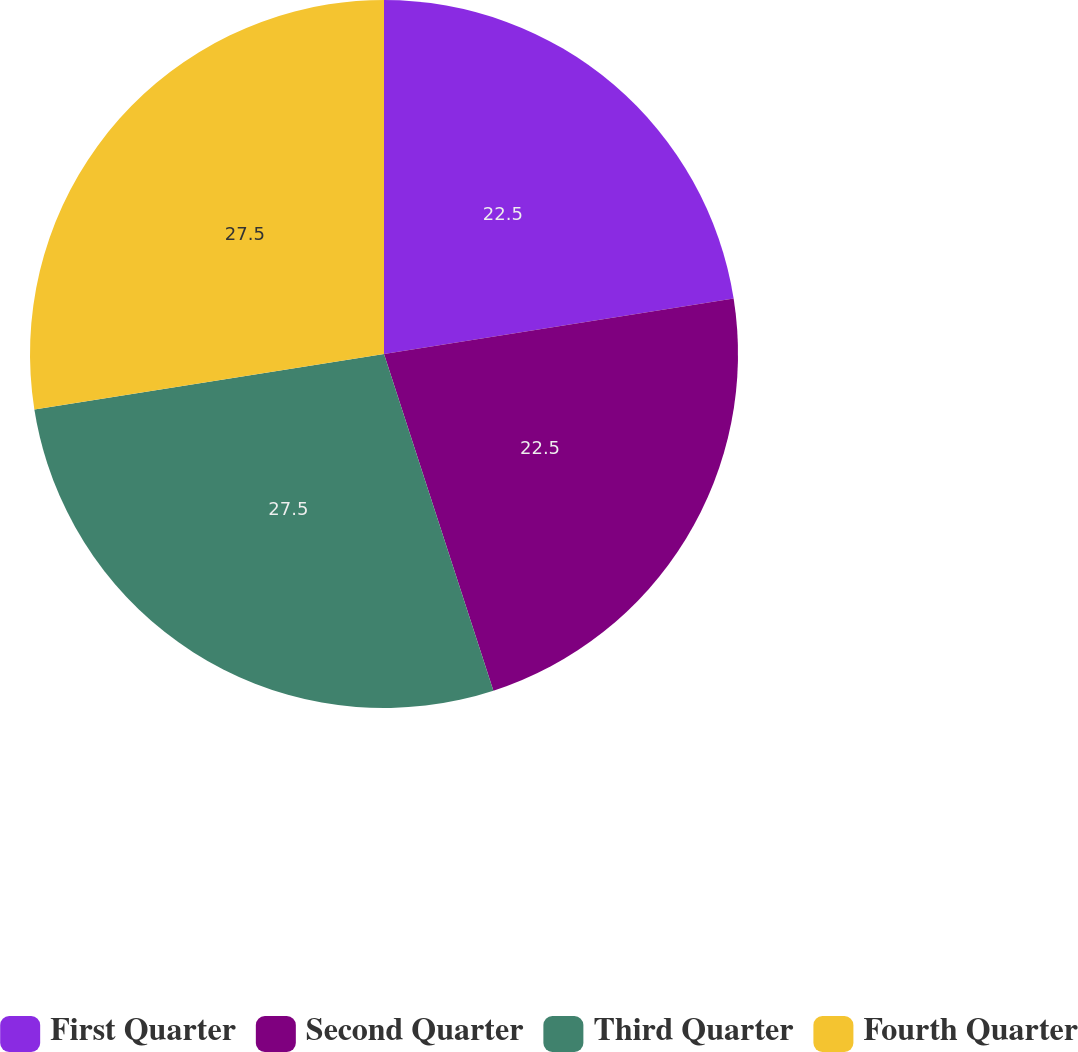Convert chart. <chart><loc_0><loc_0><loc_500><loc_500><pie_chart><fcel>First Quarter<fcel>Second Quarter<fcel>Third Quarter<fcel>Fourth Quarter<nl><fcel>22.5%<fcel>22.5%<fcel>27.5%<fcel>27.5%<nl></chart> 